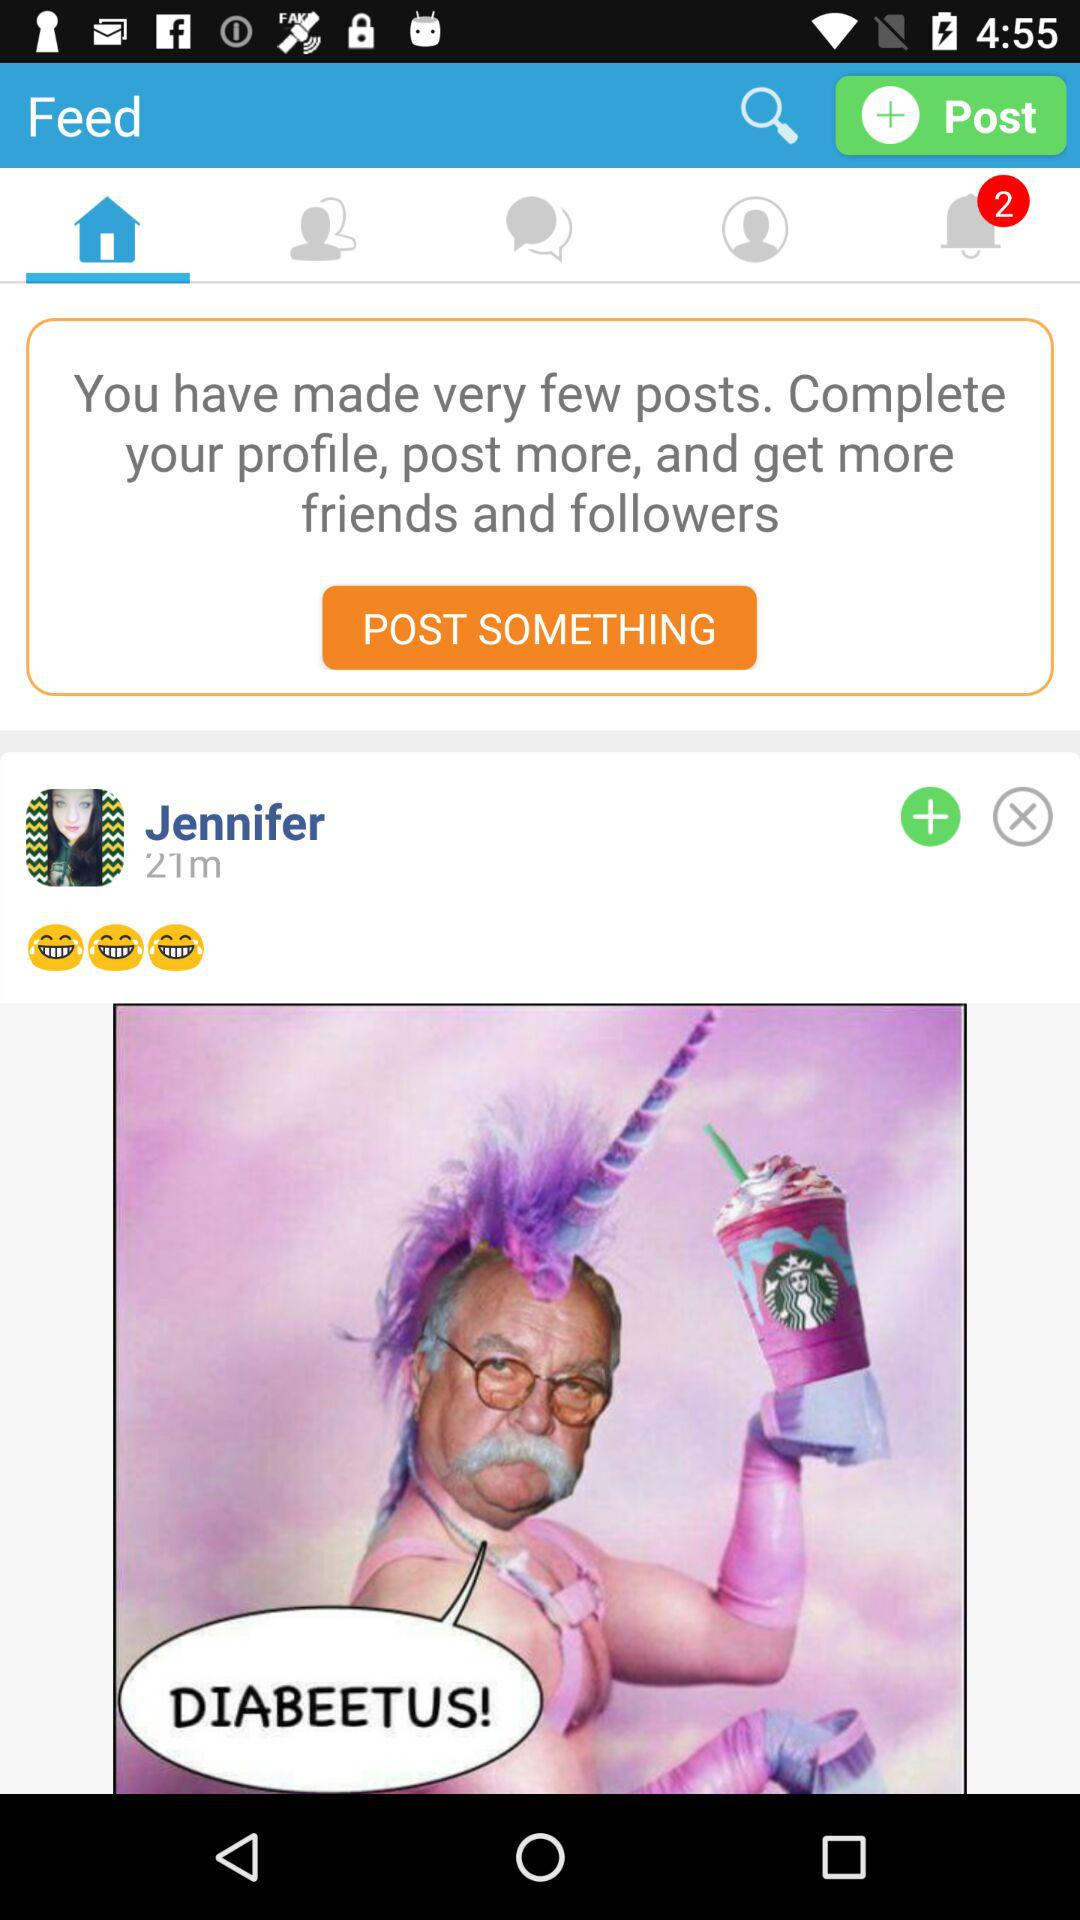What is the selected tab? The selected tab is Home. 